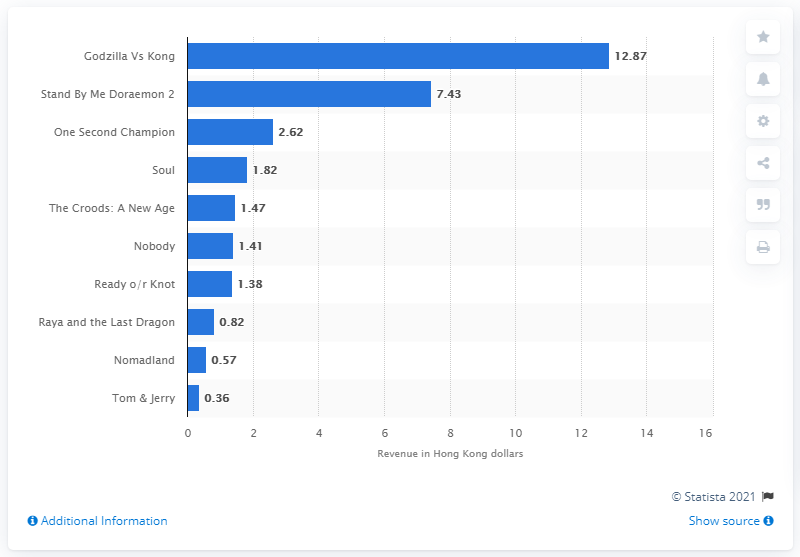Identify some key points in this picture. After 12 consecutive screening days, Godzilla vs. Kong ranked as the highest-performing movie. 